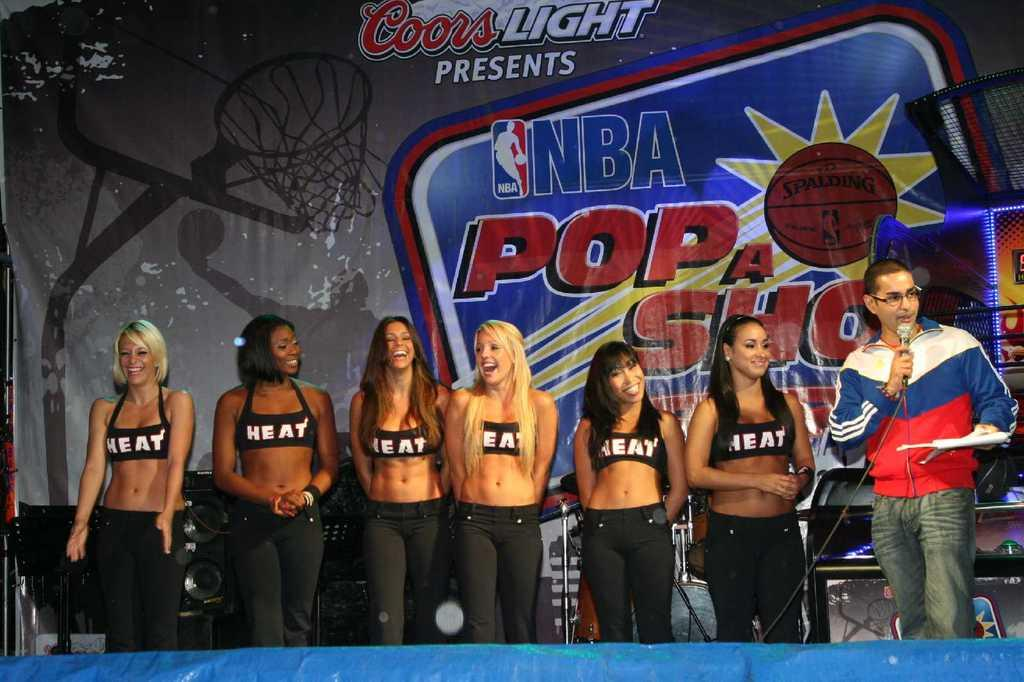<image>
Provide a brief description of the given image. A lineup of women with tops that say HEAt stand with a man in front of an NBA backdrop 